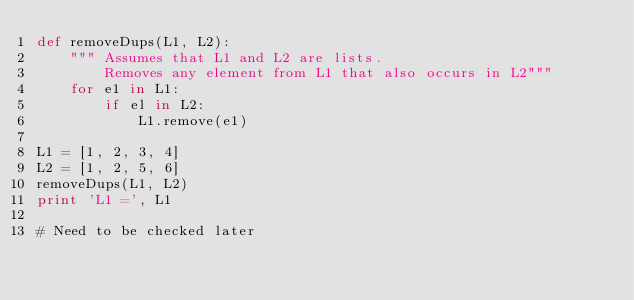<code> <loc_0><loc_0><loc_500><loc_500><_Python_>def removeDups(L1, L2):
    """ Assumes that L1 and L2 are lists.
        Removes any element from L1 that also occurs in L2"""
    for e1 in L1:
        if el in L2:
            L1.remove(e1)

L1 = [1, 2, 3, 4]
L2 = [1, 2, 5, 6]
removeDups(L1, L2)
print 'L1 =', L1 

# Need to be checked later 
</code> 